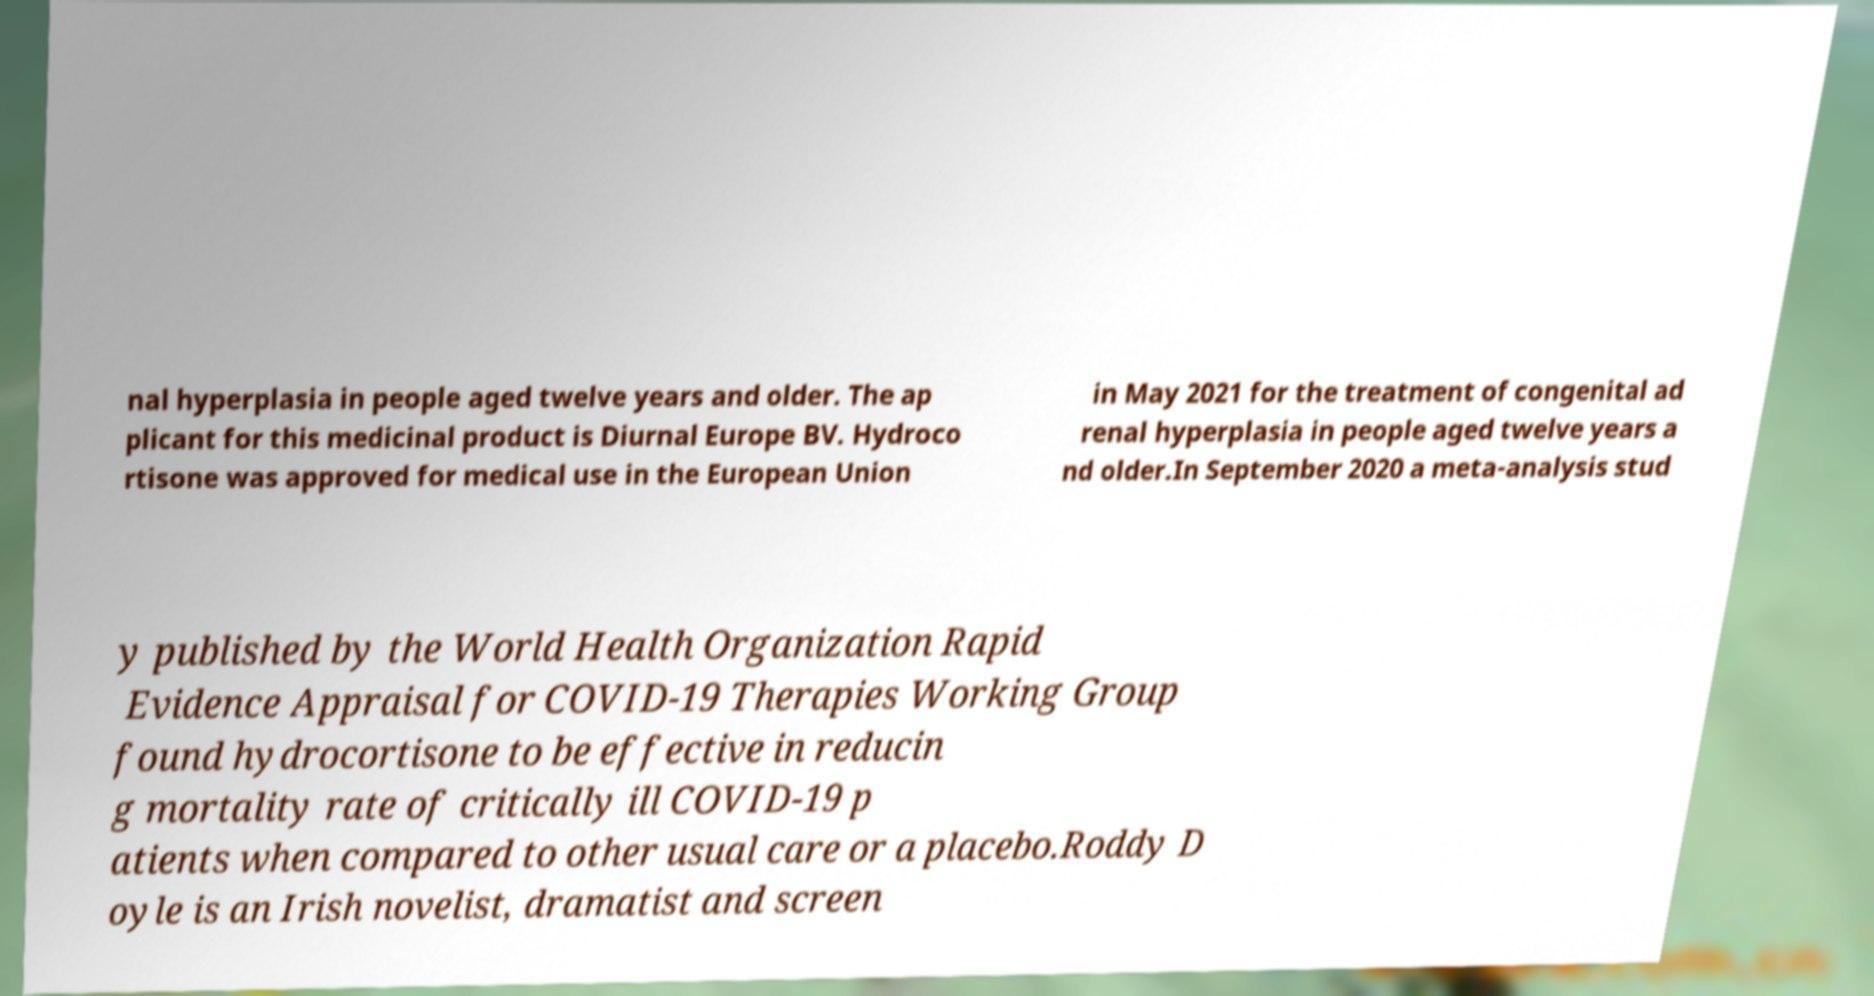Could you extract and type out the text from this image? nal hyperplasia in people aged twelve years and older. The ap plicant for this medicinal product is Diurnal Europe BV. Hydroco rtisone was approved for medical use in the European Union in May 2021 for the treatment of congenital ad renal hyperplasia in people aged twelve years a nd older.In September 2020 a meta-analysis stud y published by the World Health Organization Rapid Evidence Appraisal for COVID-19 Therapies Working Group found hydrocortisone to be effective in reducin g mortality rate of critically ill COVID-19 p atients when compared to other usual care or a placebo.Roddy D oyle is an Irish novelist, dramatist and screen 